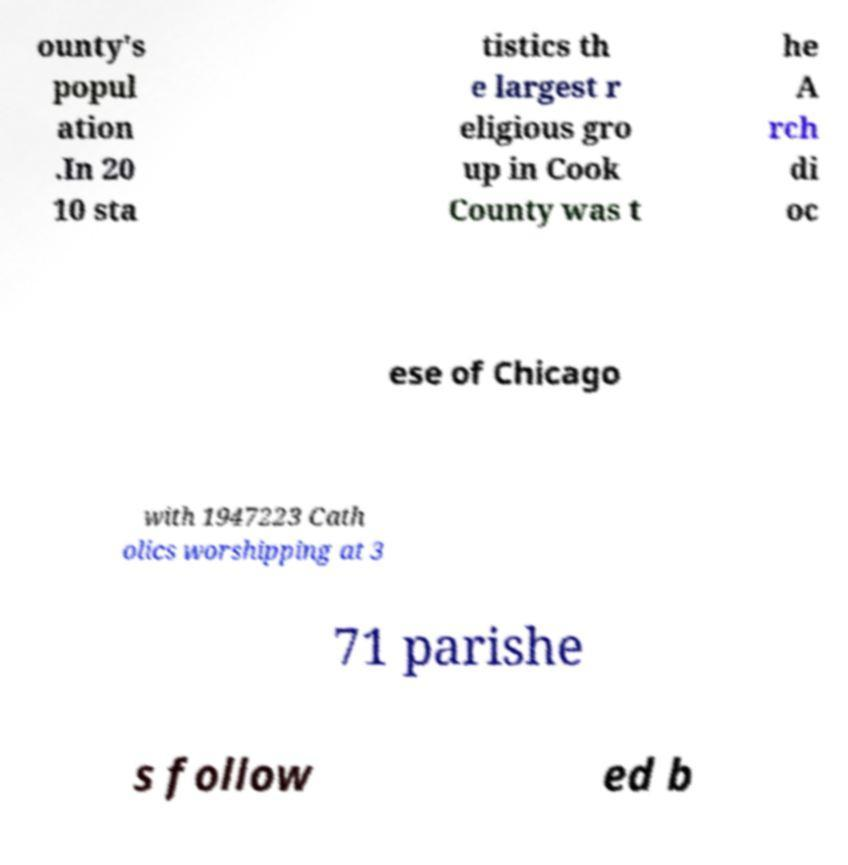What messages or text are displayed in this image? I need them in a readable, typed format. ounty's popul ation .In 20 10 sta tistics th e largest r eligious gro up in Cook County was t he A rch di oc ese of Chicago with 1947223 Cath olics worshipping at 3 71 parishe s follow ed b 